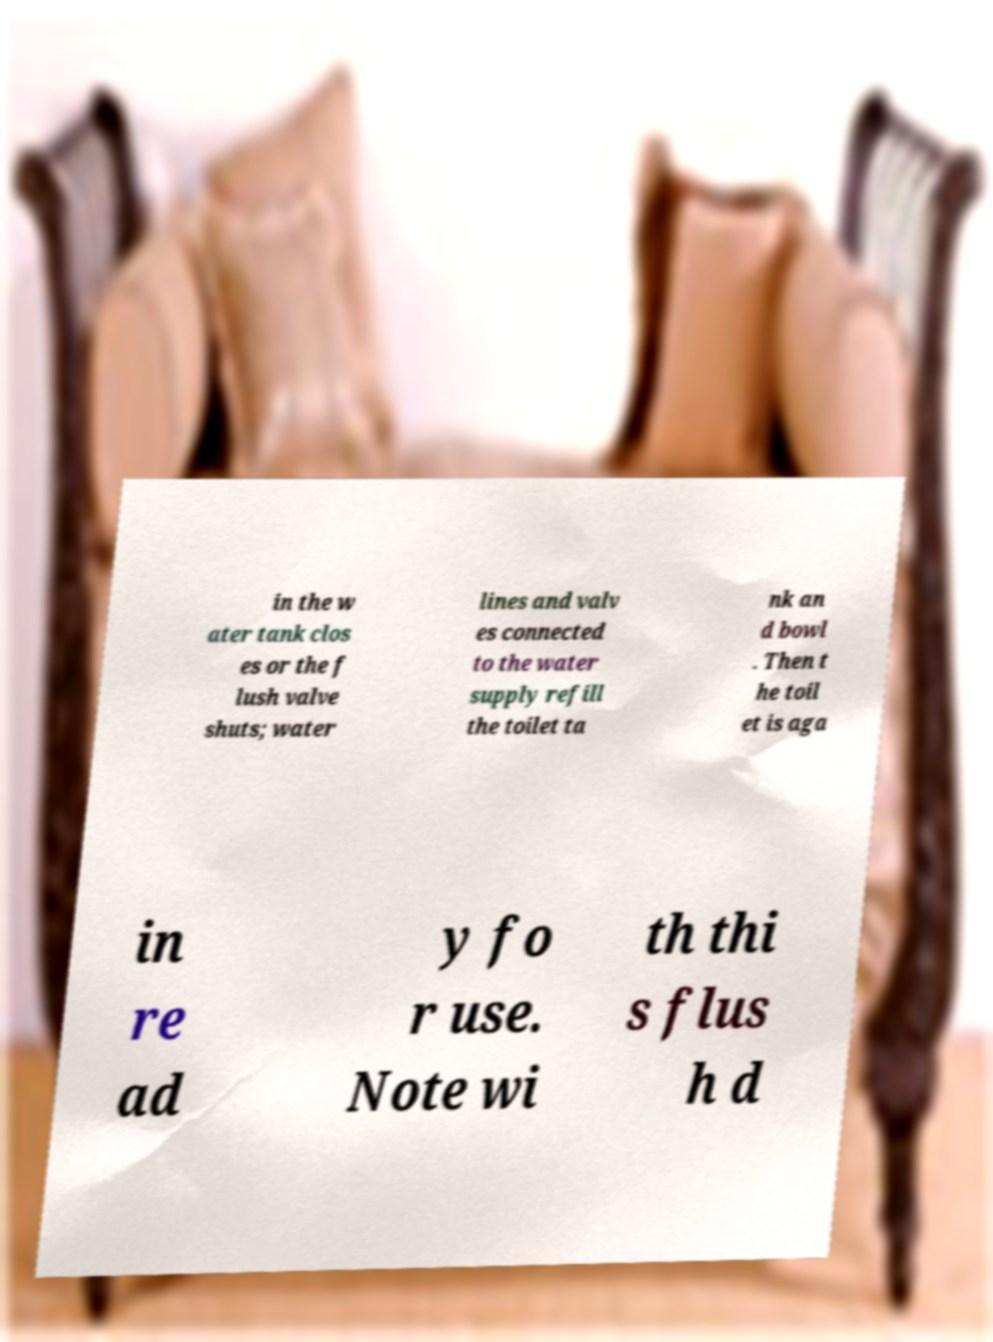Please read and relay the text visible in this image. What does it say? in the w ater tank clos es or the f lush valve shuts; water lines and valv es connected to the water supply refill the toilet ta nk an d bowl . Then t he toil et is aga in re ad y fo r use. Note wi th thi s flus h d 